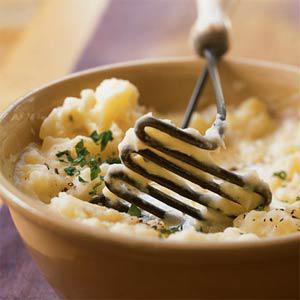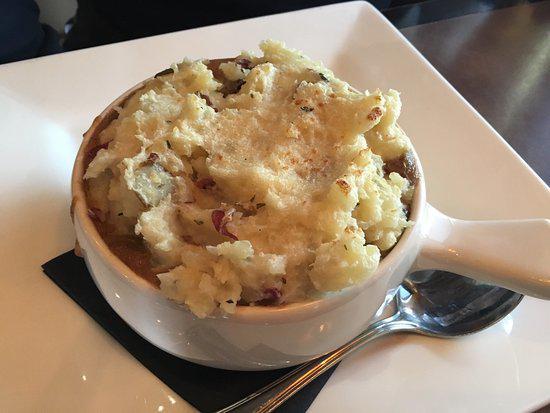The first image is the image on the left, the second image is the image on the right. Given the left and right images, does the statement "the mashed potato on the right image is shaped like a bowl of gravy." hold true? Answer yes or no. No. 